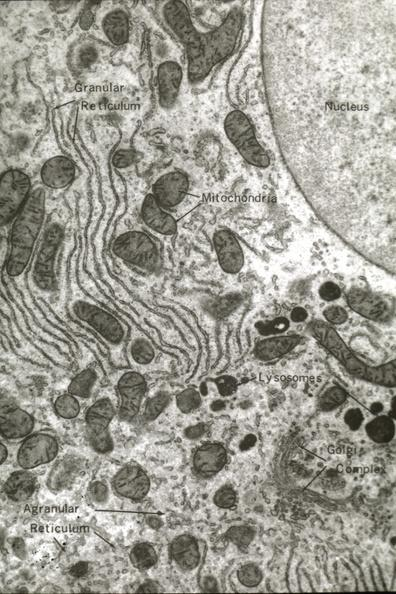s hepatobiliary present?
Answer the question using a single word or phrase. Yes 